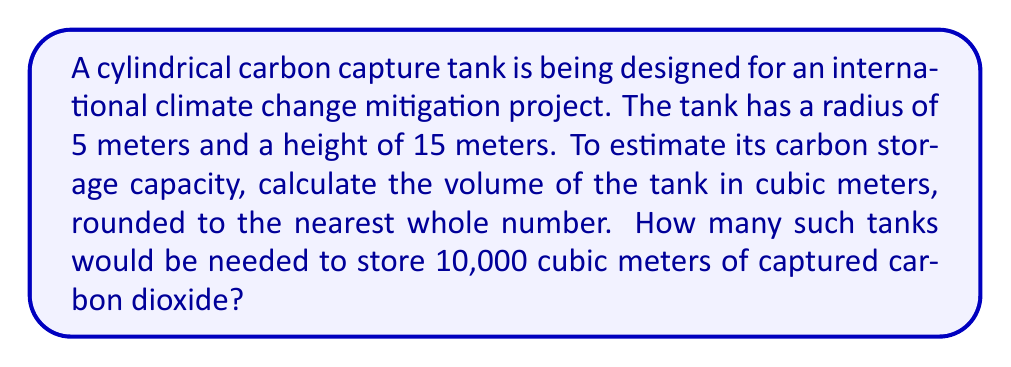What is the answer to this math problem? 1. The volume of a cylinder is given by the formula:
   $$V = \pi r^2 h$$
   where $r$ is the radius and $h$ is the height.

2. Substituting the given values:
   $$V = \pi \cdot (5\text{ m})^2 \cdot 15\text{ m}$$

3. Simplify:
   $$V = \pi \cdot 25\text{ m}^2 \cdot 15\text{ m} = 375\pi\text{ m}^3$$

4. Calculate and round to the nearest whole number:
   $$V \approx 1,178\text{ m}^3$$

5. To find the number of tanks needed to store 10,000 cubic meters:
   $$\text{Number of tanks} = \frac{10,000\text{ m}^3}{1,178\text{ m}^3} \approx 8.49$$

6. Round up to the nearest whole number, as we need full tanks:
   $$\text{Number of tanks} = 9$$
Answer: 9 tanks 